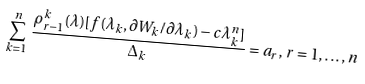<formula> <loc_0><loc_0><loc_500><loc_500>\sum _ { k = 1 } ^ { n } \frac { \rho _ { r - 1 } ^ { k } ( \lambda ) [ f ( \lambda _ { k } , \partial W _ { k } / \partial \lambda _ { k } ) - c \lambda _ { k } ^ { n } ] } { \Delta _ { k } } = a _ { r } , \, r = 1 , \dots , n</formula> 